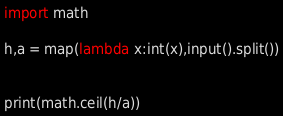Convert code to text. <code><loc_0><loc_0><loc_500><loc_500><_Python_>import math

h,a = map(lambda x:int(x),input().split())


print(math.ceil(h/a))</code> 